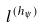Convert formula to latex. <formula><loc_0><loc_0><loc_500><loc_500>l ^ { ( h _ { \psi } ) }</formula> 